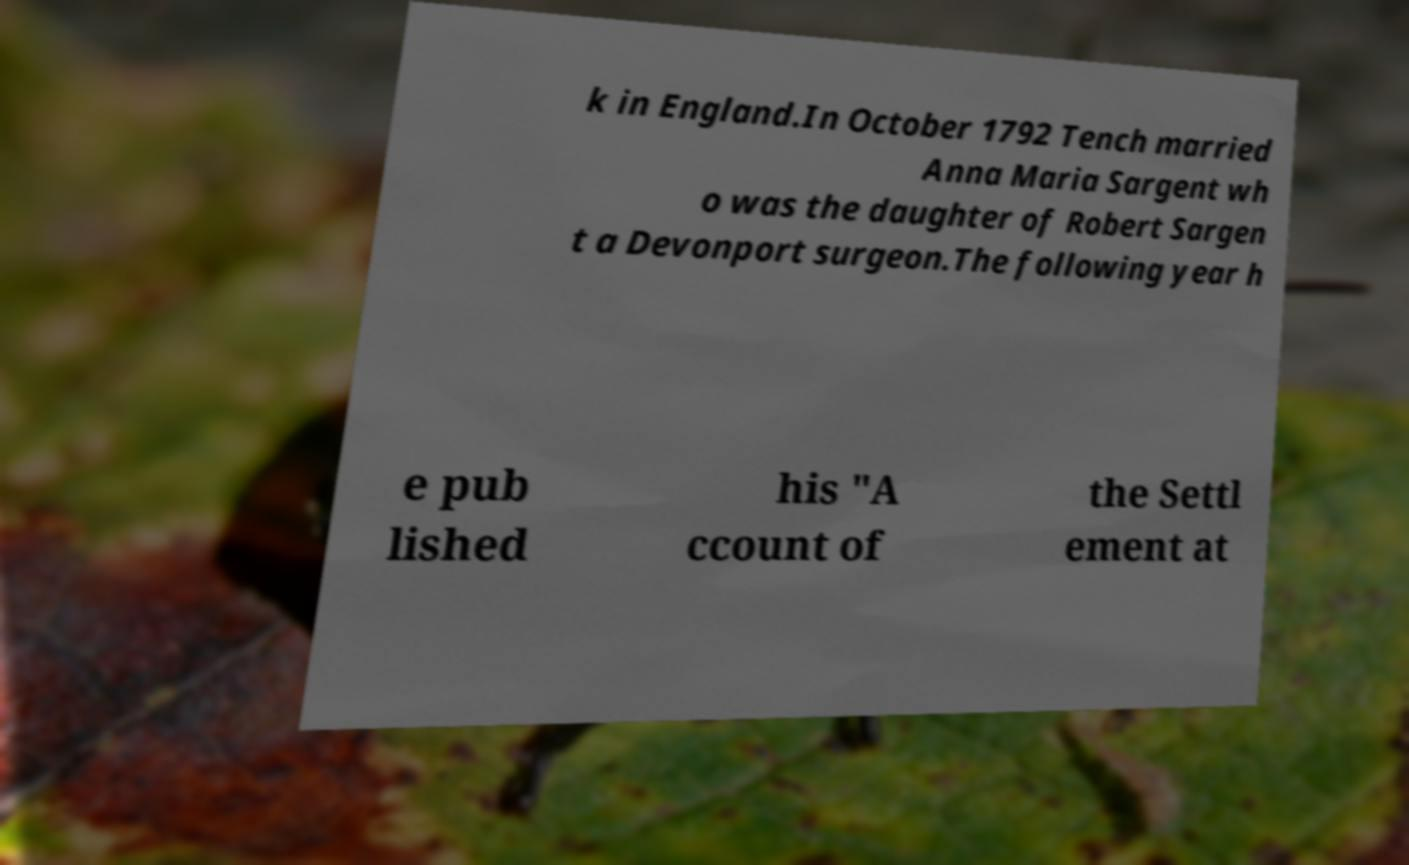Please read and relay the text visible in this image. What does it say? k in England.In October 1792 Tench married Anna Maria Sargent wh o was the daughter of Robert Sargen t a Devonport surgeon.The following year h e pub lished his "A ccount of the Settl ement at 